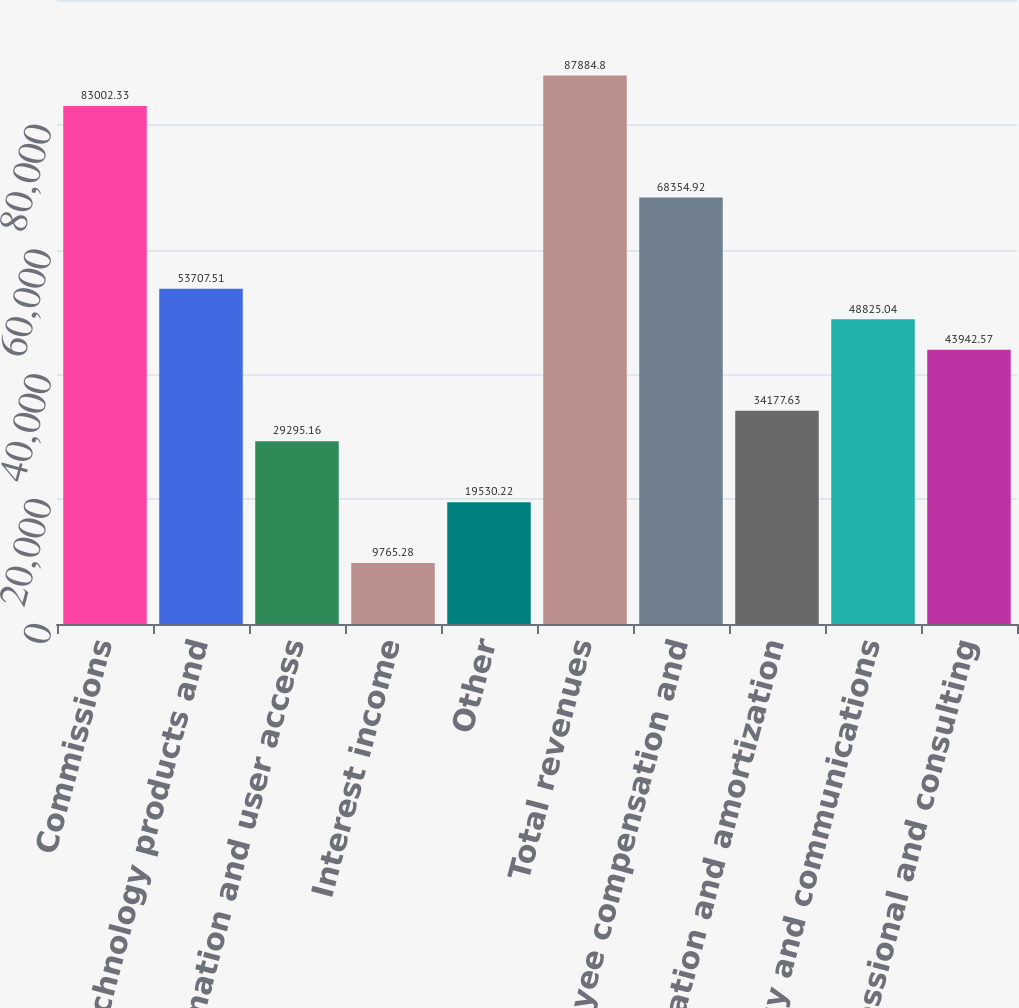Convert chart. <chart><loc_0><loc_0><loc_500><loc_500><bar_chart><fcel>Commissions<fcel>Technology products and<fcel>Information and user access<fcel>Interest income<fcel>Other<fcel>Total revenues<fcel>Employee compensation and<fcel>Depreciation and amortization<fcel>Technology and communications<fcel>Professional and consulting<nl><fcel>83002.3<fcel>53707.5<fcel>29295.2<fcel>9765.28<fcel>19530.2<fcel>87884.8<fcel>68354.9<fcel>34177.6<fcel>48825<fcel>43942.6<nl></chart> 